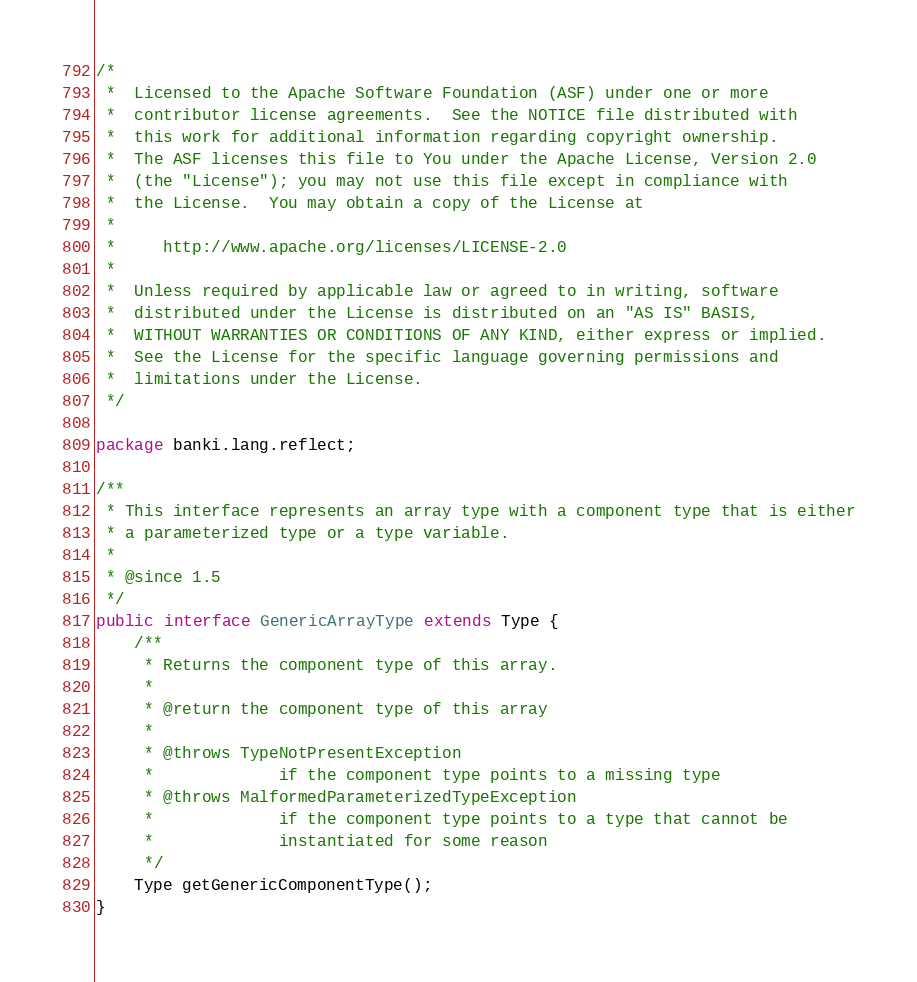<code> <loc_0><loc_0><loc_500><loc_500><_Java_>/*
 *  Licensed to the Apache Software Foundation (ASF) under one or more
 *  contributor license agreements.  See the NOTICE file distributed with
 *  this work for additional information regarding copyright ownership.
 *  The ASF licenses this file to You under the Apache License, Version 2.0
 *  (the "License"); you may not use this file except in compliance with
 *  the License.  You may obtain a copy of the License at
 *
 *     http://www.apache.org/licenses/LICENSE-2.0
 *
 *  Unless required by applicable law or agreed to in writing, software
 *  distributed under the License is distributed on an "AS IS" BASIS,
 *  WITHOUT WARRANTIES OR CONDITIONS OF ANY KIND, either express or implied.
 *  See the License for the specific language governing permissions and
 *  limitations under the License.
 */

package banki.lang.reflect;

/**
 * This interface represents an array type with a component type that is either
 * a parameterized type or a type variable.
 *
 * @since 1.5
 */
public interface GenericArrayType extends Type {
    /**
     * Returns the component type of this array.
     *
     * @return the component type of this array
     *
     * @throws TypeNotPresentException
     *             if the component type points to a missing type
     * @throws MalformedParameterizedTypeException
     *             if the component type points to a type that cannot be
     *             instantiated for some reason
     */
    Type getGenericComponentType();
}
</code> 